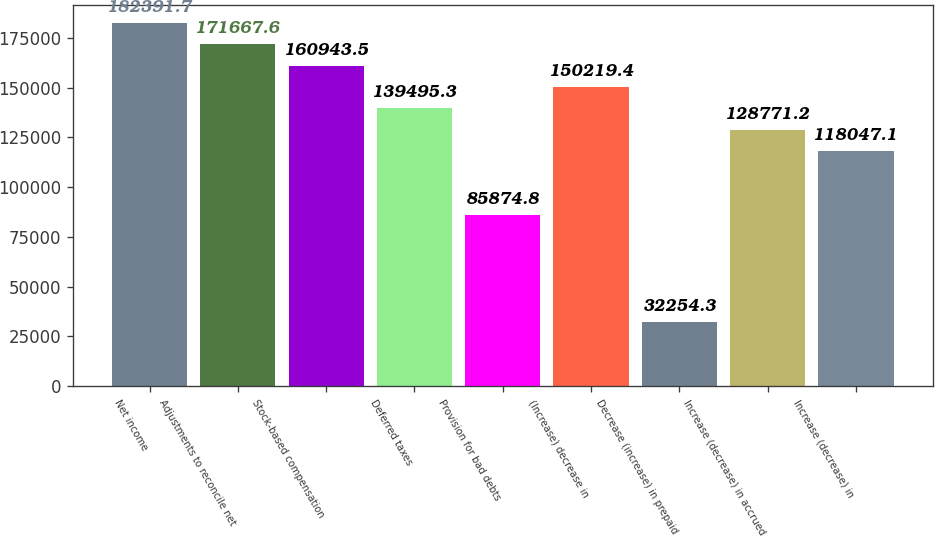<chart> <loc_0><loc_0><loc_500><loc_500><bar_chart><fcel>Net income<fcel>Adjustments to reconcile net<fcel>Stock-based compensation<fcel>Deferred taxes<fcel>Provision for bad debts<fcel>(Increase) decrease in<fcel>Decrease (increase) in prepaid<fcel>Increase (decrease) in accrued<fcel>Increase (decrease) in<nl><fcel>182392<fcel>171668<fcel>160944<fcel>139495<fcel>85874.8<fcel>150219<fcel>32254.3<fcel>128771<fcel>118047<nl></chart> 